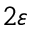Convert formula to latex. <formula><loc_0><loc_0><loc_500><loc_500>2 \varepsilon</formula> 